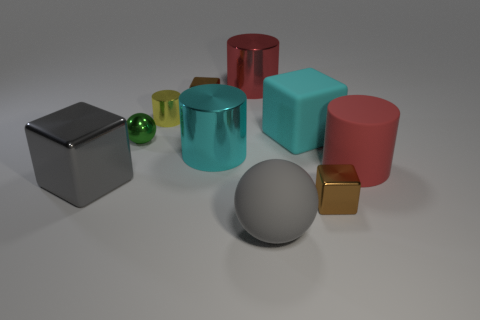Subtract all cylinders. How many objects are left? 6 Subtract 0 purple cylinders. How many objects are left? 10 Subtract all large gray shiny objects. Subtract all big cyan matte objects. How many objects are left? 8 Add 7 red objects. How many red objects are left? 9 Add 4 tiny purple metallic balls. How many tiny purple metallic balls exist? 4 